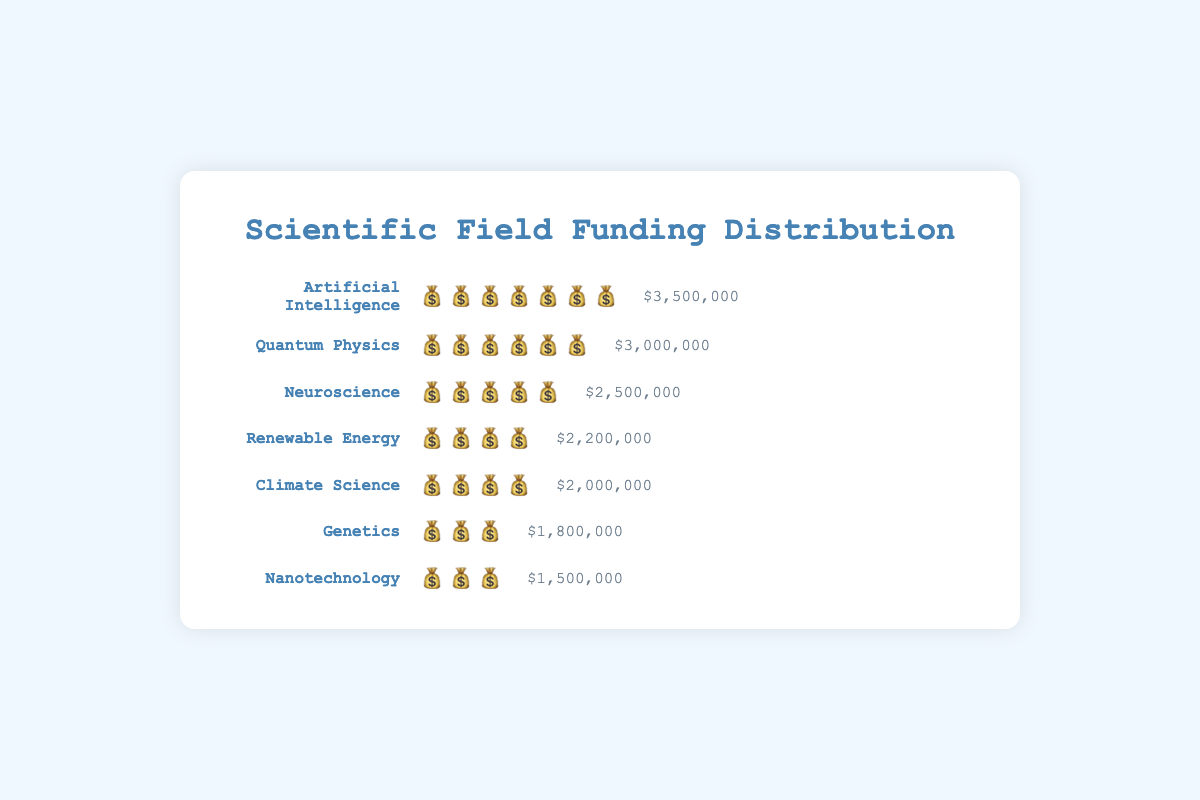What is the title of the chart? The title of the chart is located at the top and is prominently displayed. It is labeled as "Scientific Field Funding Distribution".
Answer: Scientific Field Funding Distribution Which scientific field received the highest grant funding? To find the highest grant funding, look for the bar with the most money bag emojis (💰). "Artificial Intelligence" has the most with 7 emojis.
Answer: Artificial Intelligence Which field received more funding, Genetics or Nanotechnology? To compare the funding amounts, check the number of money bag emojis (💰) next to both. Genetics has 3 emojis, and Nanotechnology also has 3 emojis which means they have equal amounts.
Answer: They received equal funding What is the total funding for both Neuroscience and Climate Science? Add up the funding amounts for Neuroscience and Climate Science. Neuroscience has $2,500,000 and Climate Science has $2,000,000. The total is $2,500,000 + $2,000,000.
Answer: $4,500,000 How much more funding did Quantum Physics receive compared to Renewable Energy? Subtract the funding amount of Renewable Energy ($2,200,000) from Quantum Physics ($3,000,000). The difference is $3,000,000 - $2,200,000.
Answer: $800,000 How many fields received funding equal to or greater than $2,000,000? Count the fields with funding amounts of $2,000,000 or more. Those are "Artificial Intelligence," "Quantum Physics," "Neuroscience," "Renewable Energy," and "Climate Science," which total to 5 fields.
Answer: 5 What is the average funding amount across all fields? Add up all the funding amounts and divide by the number of fields. Total funding is $2500000 (Neuroscience) + $3000000 (Quantum Physics) + $2000000 (Climate Science) + $1800000 (Genetics) + $3500000 (Artificial Intelligence) + $2200000 (Renewable Energy) + $1500000 (Nanotechnology) = $16,800,000. Number of fields is 7. Average is $16,800,000 / 7.
Answer: $2,400,000 Which field's funding rounds to the nearest $500,000 is $2,000,000? Round each funding amount to the nearest $500,000 and see which one ends up at $2,000,000. Climate Science has $2,000,000 which directly matches without rounding needed.
Answer: Climate Science 